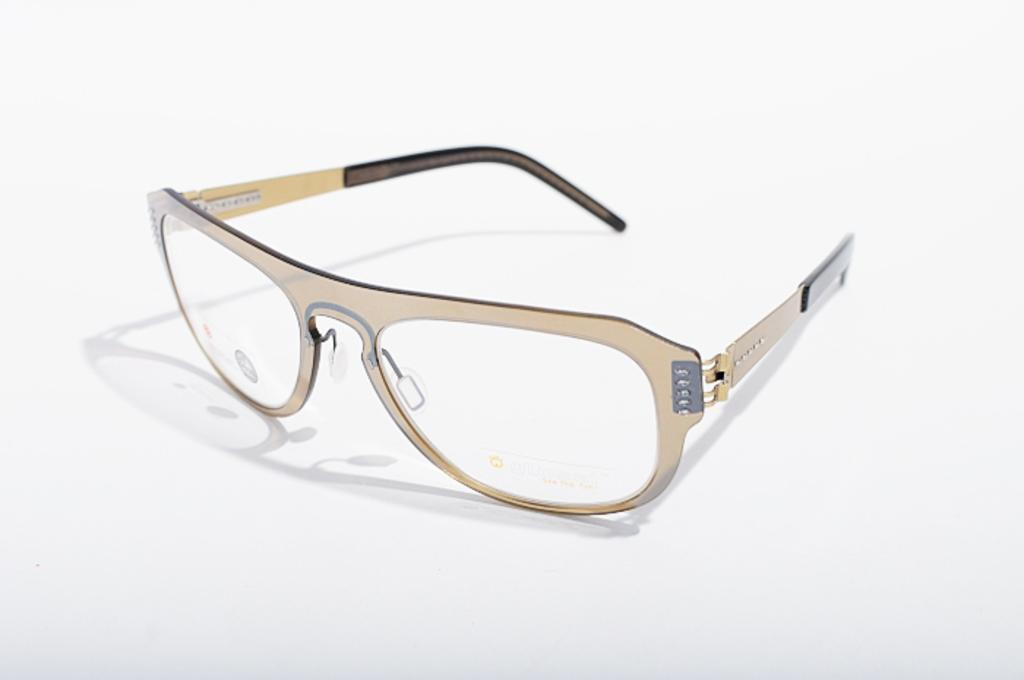What objects are present in the image? There are specs in the image. What is the color of the surface on which the specs are placed? The specs are on a white color surface. What type of birthday celebration is depicted in the image? There is no birthday celebration present in the image; it only features specs on a white surface. What part of a flight is shown in the image? There is no part of a flight present in the image; it only features specs on a white surface. 